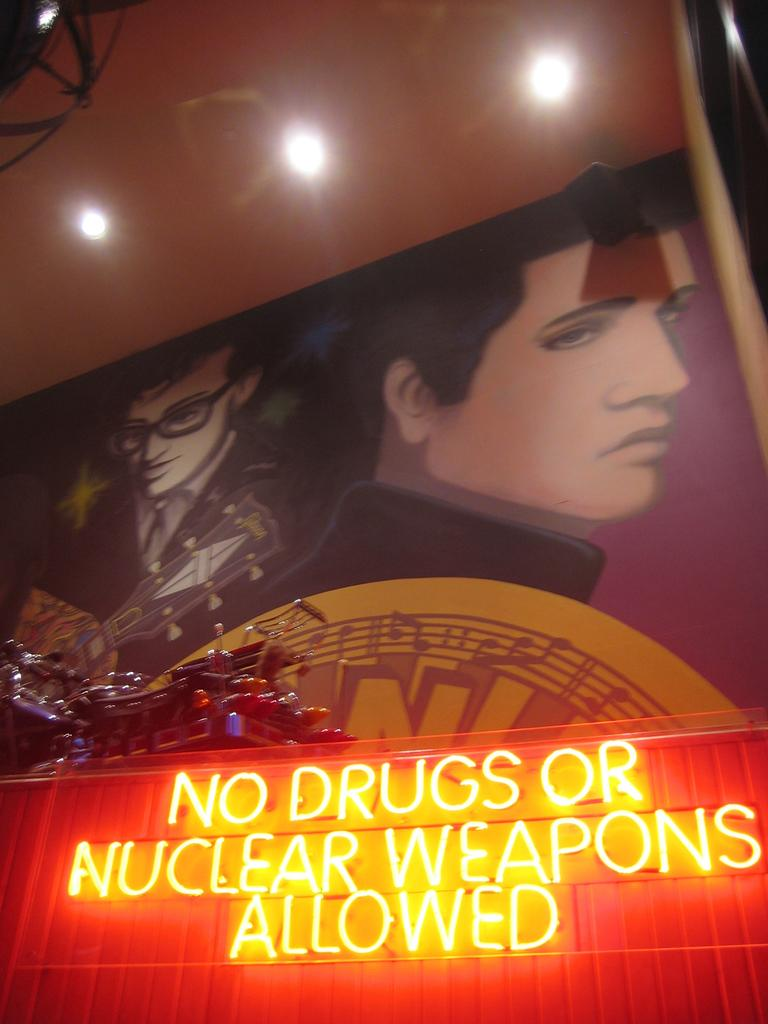<image>
Describe the image concisely. A neon sign that says No Drugs or Nuclear Weapons Allowed is in front of a motorcycle and a mural with Elvis Presley.. 